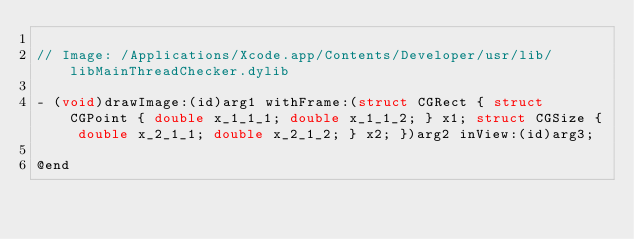Convert code to text. <code><loc_0><loc_0><loc_500><loc_500><_C_>
// Image: /Applications/Xcode.app/Contents/Developer/usr/lib/libMainThreadChecker.dylib

- (void)drawImage:(id)arg1 withFrame:(struct CGRect { struct CGPoint { double x_1_1_1; double x_1_1_2; } x1; struct CGSize { double x_2_1_1; double x_2_1_2; } x2; })arg2 inView:(id)arg3;

@end
</code> 